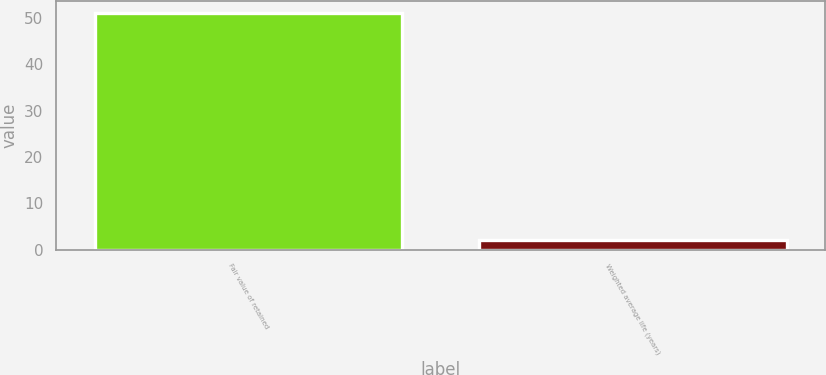<chart> <loc_0><loc_0><loc_500><loc_500><bar_chart><fcel>Fair value of retained<fcel>Weighted average life (years)<nl><fcel>51<fcel>2<nl></chart> 